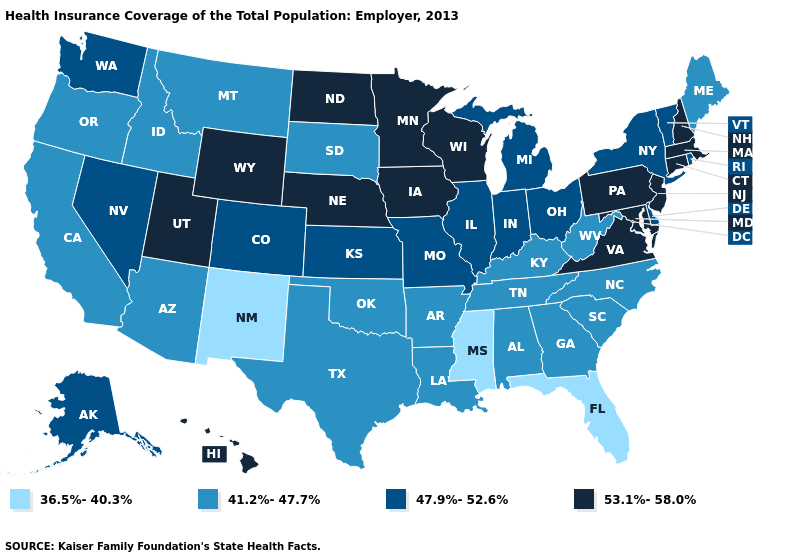Does Alabama have a lower value than Georgia?
Short answer required. No. Among the states that border Montana , does North Dakota have the highest value?
Concise answer only. Yes. What is the highest value in states that border South Dakota?
Keep it brief. 53.1%-58.0%. Name the states that have a value in the range 47.9%-52.6%?
Concise answer only. Alaska, Colorado, Delaware, Illinois, Indiana, Kansas, Michigan, Missouri, Nevada, New York, Ohio, Rhode Island, Vermont, Washington. What is the highest value in states that border Wyoming?
Be succinct. 53.1%-58.0%. Name the states that have a value in the range 41.2%-47.7%?
Write a very short answer. Alabama, Arizona, Arkansas, California, Georgia, Idaho, Kentucky, Louisiana, Maine, Montana, North Carolina, Oklahoma, Oregon, South Carolina, South Dakota, Tennessee, Texas, West Virginia. Among the states that border Texas , which have the highest value?
Give a very brief answer. Arkansas, Louisiana, Oklahoma. Does Michigan have a higher value than Iowa?
Short answer required. No. What is the highest value in the USA?
Write a very short answer. 53.1%-58.0%. What is the lowest value in the Northeast?
Give a very brief answer. 41.2%-47.7%. Which states hav the highest value in the West?
Write a very short answer. Hawaii, Utah, Wyoming. Which states hav the highest value in the West?
Keep it brief. Hawaii, Utah, Wyoming. Among the states that border Utah , which have the lowest value?
Concise answer only. New Mexico. What is the value of Alabama?
Write a very short answer. 41.2%-47.7%. Does Colorado have the lowest value in the USA?
Short answer required. No. 